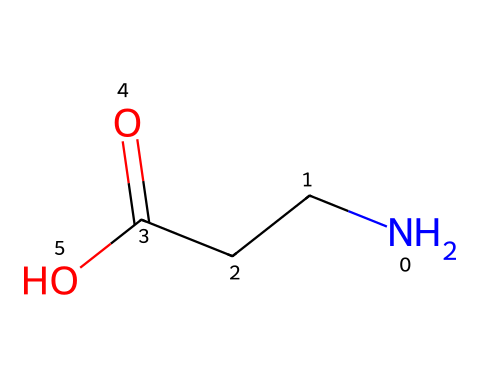How many carbon atoms are present in beta-alanine? In the SMILES representation, "NCCC(=O)O," we can count the carbon atoms represented by the "C" characters. There are three "C" characters indicating three carbon atoms in the molecule.
Answer: 3 What is the functional group present in beta-alanine? The structure contains a carboxylic acid functional group (−COOH), which is indicated by the "C(=O)O" portion of the SMILES. This reveals the presence of a carbonyl (C=O) and hydroxyl (−OH) group characteristic of carboxylic acids.
Answer: carboxylic acid What is the total number of hydrogen atoms in beta-alanine? Hydrogen atoms are typically not explicitly shown in the SMILES notation. However, we can deduce the number based on carbon and nitrogen valences. Each carbon typically forms four bonds. Here, there are three carbons already bonded to other atoms, leading to a total of seven hydrogens.
Answer: 7 Which atom in this molecule is the nitrogen atom? In the given SMILES, "N" indicates the presence of a nitrogen atom as the first character before the carbons, which corresponds to the amine portion of beta-alanine.
Answer: N What type of amino acid is beta-alanine classified as? Beta-alanine is classified as a non-proteinogenic amino acid because it is not one of the standard amino acids encoded by the nucleic acids. Its structure, which includes an amino group and a carboxylic acid, fits the general definition of amino acids, but it does not appear in proteins.
Answer: non-proteinogenic How many bonds are formed between the atoms in beta-alanine? In this molecular structure, we can count the bonds: each carbon typically forms four bonds, and nitrogen generally forms three, which collectively helps identify the connectivity. The structure shows 8 single bonds and one double bond (C=O), resulting in a total of 9 bonds overall.
Answer: 9 